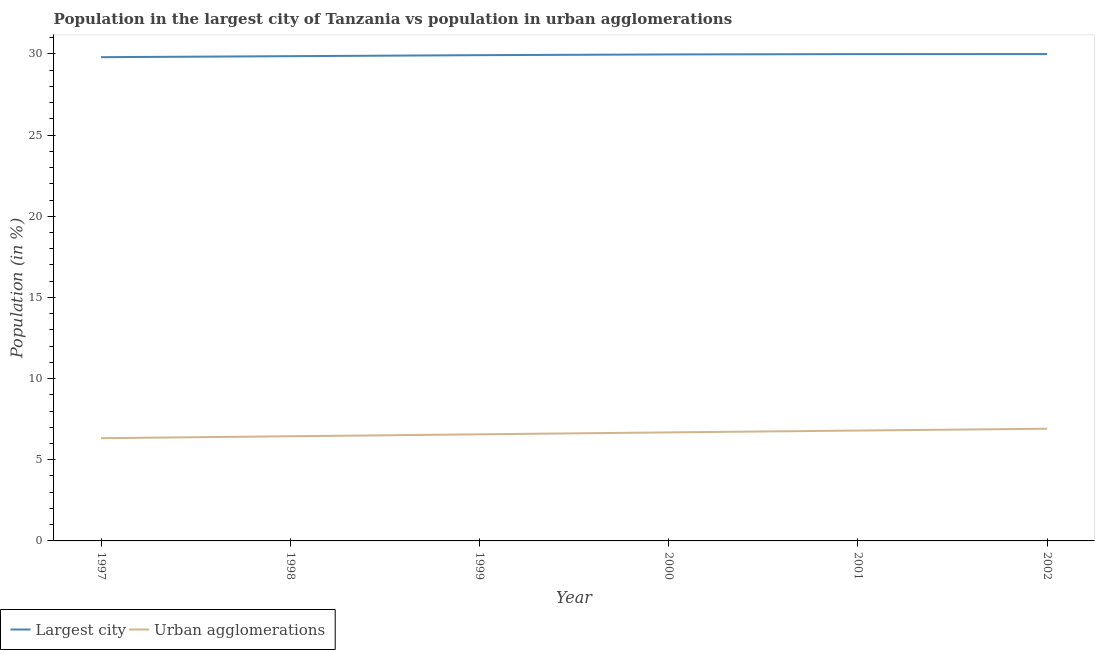How many different coloured lines are there?
Provide a short and direct response. 2. Does the line corresponding to population in urban agglomerations intersect with the line corresponding to population in the largest city?
Your response must be concise. No. What is the population in urban agglomerations in 1998?
Your response must be concise. 6.45. Across all years, what is the maximum population in the largest city?
Your response must be concise. 29.99. Across all years, what is the minimum population in urban agglomerations?
Make the answer very short. 6.33. What is the total population in the largest city in the graph?
Your answer should be compact. 179.53. What is the difference between the population in the largest city in 1997 and that in 1999?
Ensure brevity in your answer.  -0.12. What is the difference between the population in the largest city in 1998 and the population in urban agglomerations in 2001?
Your answer should be compact. 23.06. What is the average population in the largest city per year?
Provide a short and direct response. 29.92. In the year 2002, what is the difference between the population in urban agglomerations and population in the largest city?
Your answer should be very brief. -23.08. In how many years, is the population in urban agglomerations greater than 30 %?
Your answer should be very brief. 0. What is the ratio of the population in urban agglomerations in 1998 to that in 2002?
Keep it short and to the point. 0.93. Is the difference between the population in the largest city in 1997 and 2000 greater than the difference between the population in urban agglomerations in 1997 and 2000?
Offer a very short reply. Yes. What is the difference between the highest and the second highest population in the largest city?
Offer a very short reply. 0. What is the difference between the highest and the lowest population in the largest city?
Your response must be concise. 0.19. In how many years, is the population in urban agglomerations greater than the average population in urban agglomerations taken over all years?
Offer a terse response. 3. Does the population in urban agglomerations monotonically increase over the years?
Ensure brevity in your answer.  Yes. Is the population in the largest city strictly less than the population in urban agglomerations over the years?
Your answer should be compact. No. How many years are there in the graph?
Your response must be concise. 6. What is the difference between two consecutive major ticks on the Y-axis?
Your answer should be very brief. 5. Does the graph contain any zero values?
Give a very brief answer. No. Where does the legend appear in the graph?
Make the answer very short. Bottom left. What is the title of the graph?
Ensure brevity in your answer.  Population in the largest city of Tanzania vs population in urban agglomerations. Does "Nitrous oxide" appear as one of the legend labels in the graph?
Provide a succinct answer. No. What is the label or title of the X-axis?
Your answer should be compact. Year. What is the Population (in %) of Largest city in 1997?
Your response must be concise. 29.8. What is the Population (in %) in Urban agglomerations in 1997?
Provide a succinct answer. 6.33. What is the Population (in %) of Largest city in 1998?
Your response must be concise. 29.86. What is the Population (in %) of Urban agglomerations in 1998?
Your answer should be compact. 6.45. What is the Population (in %) in Largest city in 1999?
Your answer should be very brief. 29.92. What is the Population (in %) in Urban agglomerations in 1999?
Keep it short and to the point. 6.57. What is the Population (in %) of Largest city in 2000?
Provide a succinct answer. 29.97. What is the Population (in %) in Urban agglomerations in 2000?
Your answer should be very brief. 6.69. What is the Population (in %) of Largest city in 2001?
Your answer should be very brief. 29.99. What is the Population (in %) in Urban agglomerations in 2001?
Offer a very short reply. 6.8. What is the Population (in %) of Largest city in 2002?
Your response must be concise. 29.99. What is the Population (in %) of Urban agglomerations in 2002?
Offer a terse response. 6.91. Across all years, what is the maximum Population (in %) of Largest city?
Keep it short and to the point. 29.99. Across all years, what is the maximum Population (in %) in Urban agglomerations?
Your response must be concise. 6.91. Across all years, what is the minimum Population (in %) in Largest city?
Your answer should be compact. 29.8. Across all years, what is the minimum Population (in %) in Urban agglomerations?
Make the answer very short. 6.33. What is the total Population (in %) in Largest city in the graph?
Offer a terse response. 179.53. What is the total Population (in %) in Urban agglomerations in the graph?
Provide a succinct answer. 39.74. What is the difference between the Population (in %) of Largest city in 1997 and that in 1998?
Keep it short and to the point. -0.06. What is the difference between the Population (in %) in Urban agglomerations in 1997 and that in 1998?
Provide a succinct answer. -0.12. What is the difference between the Population (in %) in Largest city in 1997 and that in 1999?
Give a very brief answer. -0.12. What is the difference between the Population (in %) of Urban agglomerations in 1997 and that in 1999?
Give a very brief answer. -0.24. What is the difference between the Population (in %) of Largest city in 1997 and that in 2000?
Make the answer very short. -0.17. What is the difference between the Population (in %) of Urban agglomerations in 1997 and that in 2000?
Provide a short and direct response. -0.36. What is the difference between the Population (in %) of Largest city in 1997 and that in 2001?
Keep it short and to the point. -0.19. What is the difference between the Population (in %) in Urban agglomerations in 1997 and that in 2001?
Your answer should be very brief. -0.47. What is the difference between the Population (in %) of Largest city in 1997 and that in 2002?
Provide a succinct answer. -0.19. What is the difference between the Population (in %) in Urban agglomerations in 1997 and that in 2002?
Your answer should be very brief. -0.58. What is the difference between the Population (in %) in Largest city in 1998 and that in 1999?
Offer a very short reply. -0.06. What is the difference between the Population (in %) of Urban agglomerations in 1998 and that in 1999?
Your response must be concise. -0.12. What is the difference between the Population (in %) in Largest city in 1998 and that in 2000?
Your answer should be very brief. -0.11. What is the difference between the Population (in %) of Urban agglomerations in 1998 and that in 2000?
Keep it short and to the point. -0.24. What is the difference between the Population (in %) in Largest city in 1998 and that in 2001?
Ensure brevity in your answer.  -0.13. What is the difference between the Population (in %) in Urban agglomerations in 1998 and that in 2001?
Your answer should be very brief. -0.35. What is the difference between the Population (in %) of Largest city in 1998 and that in 2002?
Offer a terse response. -0.13. What is the difference between the Population (in %) in Urban agglomerations in 1998 and that in 2002?
Your answer should be compact. -0.46. What is the difference between the Population (in %) of Largest city in 1999 and that in 2000?
Your answer should be compact. -0.04. What is the difference between the Population (in %) of Urban agglomerations in 1999 and that in 2000?
Offer a terse response. -0.12. What is the difference between the Population (in %) in Largest city in 1999 and that in 2001?
Keep it short and to the point. -0.06. What is the difference between the Population (in %) of Urban agglomerations in 1999 and that in 2001?
Make the answer very short. -0.23. What is the difference between the Population (in %) in Largest city in 1999 and that in 2002?
Offer a terse response. -0.07. What is the difference between the Population (in %) of Urban agglomerations in 1999 and that in 2002?
Provide a short and direct response. -0.34. What is the difference between the Population (in %) in Largest city in 2000 and that in 2001?
Make the answer very short. -0.02. What is the difference between the Population (in %) in Urban agglomerations in 2000 and that in 2001?
Ensure brevity in your answer.  -0.11. What is the difference between the Population (in %) in Largest city in 2000 and that in 2002?
Provide a short and direct response. -0.02. What is the difference between the Population (in %) in Urban agglomerations in 2000 and that in 2002?
Give a very brief answer. -0.23. What is the difference between the Population (in %) of Largest city in 2001 and that in 2002?
Ensure brevity in your answer.  -0. What is the difference between the Population (in %) in Urban agglomerations in 2001 and that in 2002?
Make the answer very short. -0.11. What is the difference between the Population (in %) of Largest city in 1997 and the Population (in %) of Urban agglomerations in 1998?
Your answer should be very brief. 23.35. What is the difference between the Population (in %) of Largest city in 1997 and the Population (in %) of Urban agglomerations in 1999?
Offer a very short reply. 23.23. What is the difference between the Population (in %) of Largest city in 1997 and the Population (in %) of Urban agglomerations in 2000?
Offer a very short reply. 23.11. What is the difference between the Population (in %) of Largest city in 1997 and the Population (in %) of Urban agglomerations in 2001?
Keep it short and to the point. 23. What is the difference between the Population (in %) in Largest city in 1997 and the Population (in %) in Urban agglomerations in 2002?
Provide a short and direct response. 22.89. What is the difference between the Population (in %) of Largest city in 1998 and the Population (in %) of Urban agglomerations in 1999?
Provide a short and direct response. 23.29. What is the difference between the Population (in %) of Largest city in 1998 and the Population (in %) of Urban agglomerations in 2000?
Your answer should be very brief. 23.17. What is the difference between the Population (in %) in Largest city in 1998 and the Population (in %) in Urban agglomerations in 2001?
Offer a terse response. 23.06. What is the difference between the Population (in %) of Largest city in 1998 and the Population (in %) of Urban agglomerations in 2002?
Your answer should be very brief. 22.95. What is the difference between the Population (in %) of Largest city in 1999 and the Population (in %) of Urban agglomerations in 2000?
Your response must be concise. 23.24. What is the difference between the Population (in %) of Largest city in 1999 and the Population (in %) of Urban agglomerations in 2001?
Provide a short and direct response. 23.12. What is the difference between the Population (in %) of Largest city in 1999 and the Population (in %) of Urban agglomerations in 2002?
Keep it short and to the point. 23.01. What is the difference between the Population (in %) of Largest city in 2000 and the Population (in %) of Urban agglomerations in 2001?
Provide a succinct answer. 23.17. What is the difference between the Population (in %) in Largest city in 2000 and the Population (in %) in Urban agglomerations in 2002?
Make the answer very short. 23.06. What is the difference between the Population (in %) of Largest city in 2001 and the Population (in %) of Urban agglomerations in 2002?
Your answer should be very brief. 23.08. What is the average Population (in %) of Largest city per year?
Make the answer very short. 29.92. What is the average Population (in %) in Urban agglomerations per year?
Keep it short and to the point. 6.62. In the year 1997, what is the difference between the Population (in %) of Largest city and Population (in %) of Urban agglomerations?
Offer a very short reply. 23.47. In the year 1998, what is the difference between the Population (in %) of Largest city and Population (in %) of Urban agglomerations?
Keep it short and to the point. 23.41. In the year 1999, what is the difference between the Population (in %) of Largest city and Population (in %) of Urban agglomerations?
Ensure brevity in your answer.  23.36. In the year 2000, what is the difference between the Population (in %) in Largest city and Population (in %) in Urban agglomerations?
Make the answer very short. 23.28. In the year 2001, what is the difference between the Population (in %) in Largest city and Population (in %) in Urban agglomerations?
Your answer should be very brief. 23.19. In the year 2002, what is the difference between the Population (in %) of Largest city and Population (in %) of Urban agglomerations?
Provide a short and direct response. 23.08. What is the ratio of the Population (in %) in Largest city in 1997 to that in 1998?
Provide a short and direct response. 1. What is the ratio of the Population (in %) of Urban agglomerations in 1997 to that in 1998?
Offer a very short reply. 0.98. What is the ratio of the Population (in %) of Urban agglomerations in 1997 to that in 1999?
Make the answer very short. 0.96. What is the ratio of the Population (in %) of Urban agglomerations in 1997 to that in 2000?
Offer a terse response. 0.95. What is the ratio of the Population (in %) in Urban agglomerations in 1997 to that in 2001?
Your answer should be very brief. 0.93. What is the ratio of the Population (in %) in Largest city in 1997 to that in 2002?
Ensure brevity in your answer.  0.99. What is the ratio of the Population (in %) in Urban agglomerations in 1997 to that in 2002?
Ensure brevity in your answer.  0.92. What is the ratio of the Population (in %) in Largest city in 1998 to that in 1999?
Give a very brief answer. 1. What is the ratio of the Population (in %) in Urban agglomerations in 1998 to that in 1999?
Offer a very short reply. 0.98. What is the ratio of the Population (in %) of Largest city in 1998 to that in 2000?
Provide a succinct answer. 1. What is the ratio of the Population (in %) in Urban agglomerations in 1998 to that in 2000?
Keep it short and to the point. 0.96. What is the ratio of the Population (in %) in Largest city in 1998 to that in 2001?
Make the answer very short. 1. What is the ratio of the Population (in %) of Urban agglomerations in 1998 to that in 2001?
Make the answer very short. 0.95. What is the ratio of the Population (in %) of Largest city in 1998 to that in 2002?
Offer a very short reply. 1. What is the ratio of the Population (in %) in Urban agglomerations in 1998 to that in 2002?
Give a very brief answer. 0.93. What is the ratio of the Population (in %) of Urban agglomerations in 1999 to that in 2000?
Your answer should be compact. 0.98. What is the ratio of the Population (in %) in Urban agglomerations in 1999 to that in 2001?
Offer a very short reply. 0.97. What is the ratio of the Population (in %) in Urban agglomerations in 1999 to that in 2002?
Your answer should be compact. 0.95. What is the ratio of the Population (in %) of Largest city in 2000 to that in 2001?
Ensure brevity in your answer.  1. What is the ratio of the Population (in %) of Urban agglomerations in 2000 to that in 2001?
Give a very brief answer. 0.98. What is the ratio of the Population (in %) of Urban agglomerations in 2000 to that in 2002?
Offer a very short reply. 0.97. What is the ratio of the Population (in %) of Urban agglomerations in 2001 to that in 2002?
Your response must be concise. 0.98. What is the difference between the highest and the second highest Population (in %) of Largest city?
Your answer should be compact. 0. What is the difference between the highest and the second highest Population (in %) of Urban agglomerations?
Your response must be concise. 0.11. What is the difference between the highest and the lowest Population (in %) of Largest city?
Keep it short and to the point. 0.19. What is the difference between the highest and the lowest Population (in %) in Urban agglomerations?
Keep it short and to the point. 0.58. 